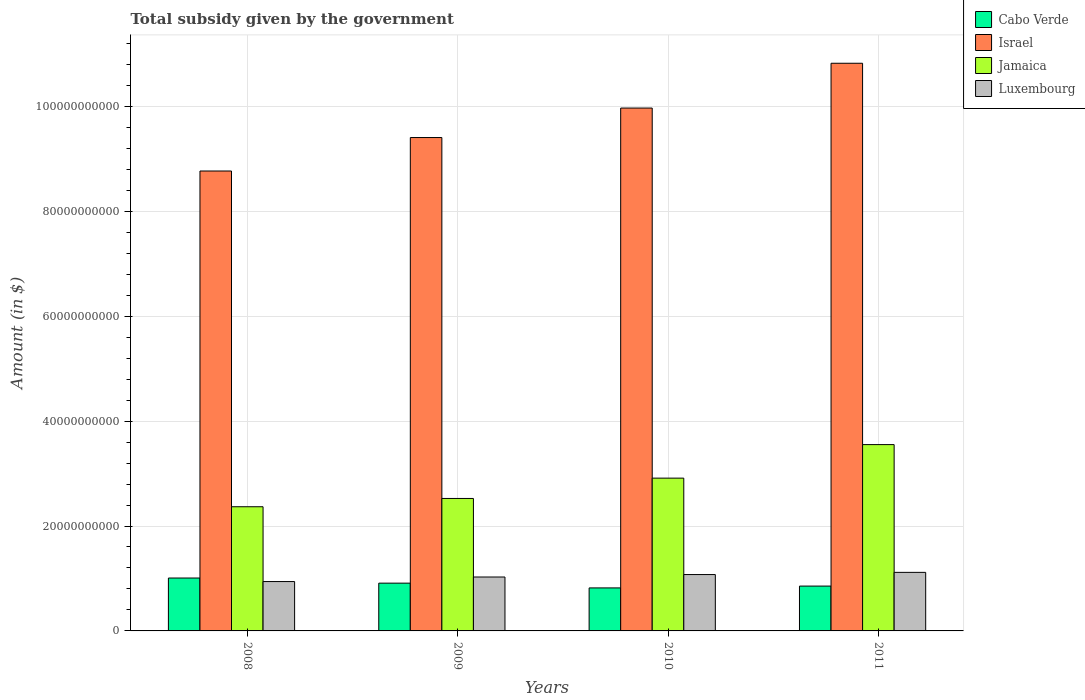How many bars are there on the 1st tick from the left?
Keep it short and to the point. 4. What is the label of the 2nd group of bars from the left?
Keep it short and to the point. 2009. What is the total revenue collected by the government in Israel in 2011?
Provide a short and direct response. 1.08e+11. Across all years, what is the maximum total revenue collected by the government in Jamaica?
Your answer should be compact. 3.55e+1. Across all years, what is the minimum total revenue collected by the government in Cabo Verde?
Offer a very short reply. 8.20e+09. In which year was the total revenue collected by the government in Jamaica maximum?
Ensure brevity in your answer.  2011. What is the total total revenue collected by the government in Luxembourg in the graph?
Ensure brevity in your answer.  4.16e+1. What is the difference between the total revenue collected by the government in Cabo Verde in 2008 and that in 2011?
Offer a very short reply. 1.54e+09. What is the difference between the total revenue collected by the government in Israel in 2008 and the total revenue collected by the government in Luxembourg in 2009?
Your answer should be very brief. 7.74e+1. What is the average total revenue collected by the government in Cabo Verde per year?
Offer a very short reply. 8.98e+09. In the year 2008, what is the difference between the total revenue collected by the government in Israel and total revenue collected by the government in Cabo Verde?
Ensure brevity in your answer.  7.76e+1. What is the ratio of the total revenue collected by the government in Luxembourg in 2009 to that in 2011?
Make the answer very short. 0.92. What is the difference between the highest and the second highest total revenue collected by the government in Jamaica?
Provide a short and direct response. 6.39e+09. What is the difference between the highest and the lowest total revenue collected by the government in Jamaica?
Your response must be concise. 1.18e+1. Is it the case that in every year, the sum of the total revenue collected by the government in Jamaica and total revenue collected by the government in Cabo Verde is greater than the sum of total revenue collected by the government in Israel and total revenue collected by the government in Luxembourg?
Your response must be concise. Yes. What does the 1st bar from the left in 2011 represents?
Give a very brief answer. Cabo Verde. What does the 4th bar from the right in 2009 represents?
Keep it short and to the point. Cabo Verde. Is it the case that in every year, the sum of the total revenue collected by the government in Luxembourg and total revenue collected by the government in Israel is greater than the total revenue collected by the government in Cabo Verde?
Offer a very short reply. Yes. Are all the bars in the graph horizontal?
Make the answer very short. No. How many years are there in the graph?
Provide a succinct answer. 4. What is the difference between two consecutive major ticks on the Y-axis?
Give a very brief answer. 2.00e+1. Are the values on the major ticks of Y-axis written in scientific E-notation?
Keep it short and to the point. No. Does the graph contain grids?
Offer a very short reply. Yes. What is the title of the graph?
Provide a short and direct response. Total subsidy given by the government. What is the label or title of the X-axis?
Your answer should be compact. Years. What is the label or title of the Y-axis?
Make the answer very short. Amount (in $). What is the Amount (in $) of Cabo Verde in 2008?
Your answer should be very brief. 1.01e+1. What is the Amount (in $) of Israel in 2008?
Give a very brief answer. 8.77e+1. What is the Amount (in $) of Jamaica in 2008?
Provide a succinct answer. 2.37e+1. What is the Amount (in $) of Luxembourg in 2008?
Offer a terse response. 9.41e+09. What is the Amount (in $) in Cabo Verde in 2009?
Offer a terse response. 9.11e+09. What is the Amount (in $) of Israel in 2009?
Your response must be concise. 9.41e+1. What is the Amount (in $) of Jamaica in 2009?
Ensure brevity in your answer.  2.53e+1. What is the Amount (in $) of Luxembourg in 2009?
Provide a succinct answer. 1.03e+1. What is the Amount (in $) in Cabo Verde in 2010?
Offer a very short reply. 8.20e+09. What is the Amount (in $) of Israel in 2010?
Provide a short and direct response. 9.97e+1. What is the Amount (in $) in Jamaica in 2010?
Ensure brevity in your answer.  2.91e+1. What is the Amount (in $) in Luxembourg in 2010?
Your answer should be compact. 1.07e+1. What is the Amount (in $) in Cabo Verde in 2011?
Your answer should be compact. 8.55e+09. What is the Amount (in $) of Israel in 2011?
Provide a succinct answer. 1.08e+11. What is the Amount (in $) in Jamaica in 2011?
Provide a succinct answer. 3.55e+1. What is the Amount (in $) of Luxembourg in 2011?
Provide a short and direct response. 1.12e+1. Across all years, what is the maximum Amount (in $) of Cabo Verde?
Make the answer very short. 1.01e+1. Across all years, what is the maximum Amount (in $) of Israel?
Provide a succinct answer. 1.08e+11. Across all years, what is the maximum Amount (in $) in Jamaica?
Your answer should be very brief. 3.55e+1. Across all years, what is the maximum Amount (in $) of Luxembourg?
Give a very brief answer. 1.12e+1. Across all years, what is the minimum Amount (in $) in Cabo Verde?
Make the answer very short. 8.20e+09. Across all years, what is the minimum Amount (in $) of Israel?
Offer a very short reply. 8.77e+1. Across all years, what is the minimum Amount (in $) of Jamaica?
Ensure brevity in your answer.  2.37e+1. Across all years, what is the minimum Amount (in $) of Luxembourg?
Give a very brief answer. 9.41e+09. What is the total Amount (in $) in Cabo Verde in the graph?
Offer a terse response. 3.59e+1. What is the total Amount (in $) in Israel in the graph?
Offer a very short reply. 3.90e+11. What is the total Amount (in $) of Jamaica in the graph?
Provide a short and direct response. 1.14e+11. What is the total Amount (in $) in Luxembourg in the graph?
Offer a terse response. 4.16e+1. What is the difference between the Amount (in $) of Cabo Verde in 2008 and that in 2009?
Your response must be concise. 9.79e+08. What is the difference between the Amount (in $) in Israel in 2008 and that in 2009?
Provide a succinct answer. -6.38e+09. What is the difference between the Amount (in $) in Jamaica in 2008 and that in 2009?
Your response must be concise. -1.58e+09. What is the difference between the Amount (in $) of Luxembourg in 2008 and that in 2009?
Provide a succinct answer. -8.68e+08. What is the difference between the Amount (in $) in Cabo Verde in 2008 and that in 2010?
Give a very brief answer. 1.89e+09. What is the difference between the Amount (in $) in Israel in 2008 and that in 2010?
Ensure brevity in your answer.  -1.20e+1. What is the difference between the Amount (in $) of Jamaica in 2008 and that in 2010?
Your answer should be compact. -5.46e+09. What is the difference between the Amount (in $) in Luxembourg in 2008 and that in 2010?
Your answer should be very brief. -1.33e+09. What is the difference between the Amount (in $) in Cabo Verde in 2008 and that in 2011?
Offer a very short reply. 1.54e+09. What is the difference between the Amount (in $) in Israel in 2008 and that in 2011?
Provide a succinct answer. -2.05e+1. What is the difference between the Amount (in $) in Jamaica in 2008 and that in 2011?
Offer a very short reply. -1.18e+1. What is the difference between the Amount (in $) in Luxembourg in 2008 and that in 2011?
Provide a succinct answer. -1.75e+09. What is the difference between the Amount (in $) in Cabo Verde in 2009 and that in 2010?
Make the answer very short. 9.08e+08. What is the difference between the Amount (in $) of Israel in 2009 and that in 2010?
Provide a short and direct response. -5.62e+09. What is the difference between the Amount (in $) in Jamaica in 2009 and that in 2010?
Provide a short and direct response. -3.88e+09. What is the difference between the Amount (in $) of Luxembourg in 2009 and that in 2010?
Offer a terse response. -4.66e+08. What is the difference between the Amount (in $) in Cabo Verde in 2009 and that in 2011?
Provide a short and direct response. 5.60e+08. What is the difference between the Amount (in $) in Israel in 2009 and that in 2011?
Ensure brevity in your answer.  -1.42e+1. What is the difference between the Amount (in $) of Jamaica in 2009 and that in 2011?
Offer a terse response. -1.03e+1. What is the difference between the Amount (in $) of Luxembourg in 2009 and that in 2011?
Give a very brief answer. -8.83e+08. What is the difference between the Amount (in $) of Cabo Verde in 2010 and that in 2011?
Ensure brevity in your answer.  -3.49e+08. What is the difference between the Amount (in $) in Israel in 2010 and that in 2011?
Provide a succinct answer. -8.54e+09. What is the difference between the Amount (in $) of Jamaica in 2010 and that in 2011?
Offer a terse response. -6.39e+09. What is the difference between the Amount (in $) of Luxembourg in 2010 and that in 2011?
Ensure brevity in your answer.  -4.17e+08. What is the difference between the Amount (in $) of Cabo Verde in 2008 and the Amount (in $) of Israel in 2009?
Your response must be concise. -8.40e+1. What is the difference between the Amount (in $) of Cabo Verde in 2008 and the Amount (in $) of Jamaica in 2009?
Your response must be concise. -1.52e+1. What is the difference between the Amount (in $) of Cabo Verde in 2008 and the Amount (in $) of Luxembourg in 2009?
Make the answer very short. -1.94e+08. What is the difference between the Amount (in $) of Israel in 2008 and the Amount (in $) of Jamaica in 2009?
Make the answer very short. 6.24e+1. What is the difference between the Amount (in $) in Israel in 2008 and the Amount (in $) in Luxembourg in 2009?
Provide a short and direct response. 7.74e+1. What is the difference between the Amount (in $) in Jamaica in 2008 and the Amount (in $) in Luxembourg in 2009?
Your answer should be very brief. 1.34e+1. What is the difference between the Amount (in $) in Cabo Verde in 2008 and the Amount (in $) in Israel in 2010?
Provide a short and direct response. -8.96e+1. What is the difference between the Amount (in $) in Cabo Verde in 2008 and the Amount (in $) in Jamaica in 2010?
Provide a succinct answer. -1.90e+1. What is the difference between the Amount (in $) of Cabo Verde in 2008 and the Amount (in $) of Luxembourg in 2010?
Ensure brevity in your answer.  -6.60e+08. What is the difference between the Amount (in $) of Israel in 2008 and the Amount (in $) of Jamaica in 2010?
Your response must be concise. 5.85e+1. What is the difference between the Amount (in $) of Israel in 2008 and the Amount (in $) of Luxembourg in 2010?
Your answer should be very brief. 7.69e+1. What is the difference between the Amount (in $) of Jamaica in 2008 and the Amount (in $) of Luxembourg in 2010?
Provide a short and direct response. 1.29e+1. What is the difference between the Amount (in $) in Cabo Verde in 2008 and the Amount (in $) in Israel in 2011?
Offer a terse response. -9.81e+1. What is the difference between the Amount (in $) of Cabo Verde in 2008 and the Amount (in $) of Jamaica in 2011?
Your answer should be very brief. -2.54e+1. What is the difference between the Amount (in $) of Cabo Verde in 2008 and the Amount (in $) of Luxembourg in 2011?
Make the answer very short. -1.08e+09. What is the difference between the Amount (in $) in Israel in 2008 and the Amount (in $) in Jamaica in 2011?
Offer a terse response. 5.22e+1. What is the difference between the Amount (in $) in Israel in 2008 and the Amount (in $) in Luxembourg in 2011?
Ensure brevity in your answer.  7.65e+1. What is the difference between the Amount (in $) of Jamaica in 2008 and the Amount (in $) of Luxembourg in 2011?
Ensure brevity in your answer.  1.25e+1. What is the difference between the Amount (in $) of Cabo Verde in 2009 and the Amount (in $) of Israel in 2010?
Offer a very short reply. -9.06e+1. What is the difference between the Amount (in $) in Cabo Verde in 2009 and the Amount (in $) in Jamaica in 2010?
Your answer should be very brief. -2.00e+1. What is the difference between the Amount (in $) in Cabo Verde in 2009 and the Amount (in $) in Luxembourg in 2010?
Provide a short and direct response. -1.64e+09. What is the difference between the Amount (in $) of Israel in 2009 and the Amount (in $) of Jamaica in 2010?
Your answer should be very brief. 6.49e+1. What is the difference between the Amount (in $) in Israel in 2009 and the Amount (in $) in Luxembourg in 2010?
Give a very brief answer. 8.33e+1. What is the difference between the Amount (in $) in Jamaica in 2009 and the Amount (in $) in Luxembourg in 2010?
Your answer should be compact. 1.45e+1. What is the difference between the Amount (in $) of Cabo Verde in 2009 and the Amount (in $) of Israel in 2011?
Your response must be concise. -9.91e+1. What is the difference between the Amount (in $) in Cabo Verde in 2009 and the Amount (in $) in Jamaica in 2011?
Ensure brevity in your answer.  -2.64e+1. What is the difference between the Amount (in $) in Cabo Verde in 2009 and the Amount (in $) in Luxembourg in 2011?
Provide a short and direct response. -2.06e+09. What is the difference between the Amount (in $) of Israel in 2009 and the Amount (in $) of Jamaica in 2011?
Your answer should be compact. 5.85e+1. What is the difference between the Amount (in $) in Israel in 2009 and the Amount (in $) in Luxembourg in 2011?
Ensure brevity in your answer.  8.29e+1. What is the difference between the Amount (in $) in Jamaica in 2009 and the Amount (in $) in Luxembourg in 2011?
Provide a succinct answer. 1.41e+1. What is the difference between the Amount (in $) of Cabo Verde in 2010 and the Amount (in $) of Israel in 2011?
Your response must be concise. -1.00e+11. What is the difference between the Amount (in $) of Cabo Verde in 2010 and the Amount (in $) of Jamaica in 2011?
Your answer should be compact. -2.73e+1. What is the difference between the Amount (in $) of Cabo Verde in 2010 and the Amount (in $) of Luxembourg in 2011?
Give a very brief answer. -2.96e+09. What is the difference between the Amount (in $) in Israel in 2010 and the Amount (in $) in Jamaica in 2011?
Give a very brief answer. 6.42e+1. What is the difference between the Amount (in $) of Israel in 2010 and the Amount (in $) of Luxembourg in 2011?
Offer a very short reply. 8.85e+1. What is the difference between the Amount (in $) of Jamaica in 2010 and the Amount (in $) of Luxembourg in 2011?
Offer a terse response. 1.80e+1. What is the average Amount (in $) in Cabo Verde per year?
Give a very brief answer. 8.98e+09. What is the average Amount (in $) in Israel per year?
Provide a succinct answer. 9.74e+1. What is the average Amount (in $) of Jamaica per year?
Provide a short and direct response. 2.84e+1. What is the average Amount (in $) in Luxembourg per year?
Your answer should be very brief. 1.04e+1. In the year 2008, what is the difference between the Amount (in $) in Cabo Verde and Amount (in $) in Israel?
Make the answer very short. -7.76e+1. In the year 2008, what is the difference between the Amount (in $) of Cabo Verde and Amount (in $) of Jamaica?
Offer a very short reply. -1.36e+1. In the year 2008, what is the difference between the Amount (in $) of Cabo Verde and Amount (in $) of Luxembourg?
Offer a terse response. 6.74e+08. In the year 2008, what is the difference between the Amount (in $) in Israel and Amount (in $) in Jamaica?
Keep it short and to the point. 6.40e+1. In the year 2008, what is the difference between the Amount (in $) in Israel and Amount (in $) in Luxembourg?
Offer a very short reply. 7.83e+1. In the year 2008, what is the difference between the Amount (in $) of Jamaica and Amount (in $) of Luxembourg?
Provide a short and direct response. 1.43e+1. In the year 2009, what is the difference between the Amount (in $) of Cabo Verde and Amount (in $) of Israel?
Provide a short and direct response. -8.50e+1. In the year 2009, what is the difference between the Amount (in $) of Cabo Verde and Amount (in $) of Jamaica?
Offer a terse response. -1.61e+1. In the year 2009, what is the difference between the Amount (in $) of Cabo Verde and Amount (in $) of Luxembourg?
Provide a short and direct response. -1.17e+09. In the year 2009, what is the difference between the Amount (in $) of Israel and Amount (in $) of Jamaica?
Offer a terse response. 6.88e+1. In the year 2009, what is the difference between the Amount (in $) of Israel and Amount (in $) of Luxembourg?
Give a very brief answer. 8.38e+1. In the year 2009, what is the difference between the Amount (in $) of Jamaica and Amount (in $) of Luxembourg?
Give a very brief answer. 1.50e+1. In the year 2010, what is the difference between the Amount (in $) in Cabo Verde and Amount (in $) in Israel?
Provide a short and direct response. -9.15e+1. In the year 2010, what is the difference between the Amount (in $) of Cabo Verde and Amount (in $) of Jamaica?
Your answer should be compact. -2.09e+1. In the year 2010, what is the difference between the Amount (in $) of Cabo Verde and Amount (in $) of Luxembourg?
Your answer should be compact. -2.55e+09. In the year 2010, what is the difference between the Amount (in $) of Israel and Amount (in $) of Jamaica?
Your response must be concise. 7.06e+1. In the year 2010, what is the difference between the Amount (in $) in Israel and Amount (in $) in Luxembourg?
Your answer should be compact. 8.89e+1. In the year 2010, what is the difference between the Amount (in $) in Jamaica and Amount (in $) in Luxembourg?
Keep it short and to the point. 1.84e+1. In the year 2011, what is the difference between the Amount (in $) of Cabo Verde and Amount (in $) of Israel?
Your answer should be compact. -9.97e+1. In the year 2011, what is the difference between the Amount (in $) in Cabo Verde and Amount (in $) in Jamaica?
Ensure brevity in your answer.  -2.70e+1. In the year 2011, what is the difference between the Amount (in $) of Cabo Verde and Amount (in $) of Luxembourg?
Offer a terse response. -2.62e+09. In the year 2011, what is the difference between the Amount (in $) in Israel and Amount (in $) in Jamaica?
Offer a terse response. 7.27e+1. In the year 2011, what is the difference between the Amount (in $) of Israel and Amount (in $) of Luxembourg?
Ensure brevity in your answer.  9.71e+1. In the year 2011, what is the difference between the Amount (in $) in Jamaica and Amount (in $) in Luxembourg?
Provide a short and direct response. 2.44e+1. What is the ratio of the Amount (in $) in Cabo Verde in 2008 to that in 2009?
Make the answer very short. 1.11. What is the ratio of the Amount (in $) in Israel in 2008 to that in 2009?
Offer a very short reply. 0.93. What is the ratio of the Amount (in $) of Jamaica in 2008 to that in 2009?
Ensure brevity in your answer.  0.94. What is the ratio of the Amount (in $) in Luxembourg in 2008 to that in 2009?
Provide a succinct answer. 0.92. What is the ratio of the Amount (in $) in Cabo Verde in 2008 to that in 2010?
Your answer should be compact. 1.23. What is the ratio of the Amount (in $) of Israel in 2008 to that in 2010?
Keep it short and to the point. 0.88. What is the ratio of the Amount (in $) of Jamaica in 2008 to that in 2010?
Make the answer very short. 0.81. What is the ratio of the Amount (in $) in Luxembourg in 2008 to that in 2010?
Offer a very short reply. 0.88. What is the ratio of the Amount (in $) of Cabo Verde in 2008 to that in 2011?
Make the answer very short. 1.18. What is the ratio of the Amount (in $) of Israel in 2008 to that in 2011?
Your answer should be very brief. 0.81. What is the ratio of the Amount (in $) of Jamaica in 2008 to that in 2011?
Your answer should be very brief. 0.67. What is the ratio of the Amount (in $) in Luxembourg in 2008 to that in 2011?
Make the answer very short. 0.84. What is the ratio of the Amount (in $) in Cabo Verde in 2009 to that in 2010?
Offer a very short reply. 1.11. What is the ratio of the Amount (in $) of Israel in 2009 to that in 2010?
Keep it short and to the point. 0.94. What is the ratio of the Amount (in $) in Jamaica in 2009 to that in 2010?
Give a very brief answer. 0.87. What is the ratio of the Amount (in $) of Luxembourg in 2009 to that in 2010?
Your answer should be compact. 0.96. What is the ratio of the Amount (in $) of Cabo Verde in 2009 to that in 2011?
Provide a short and direct response. 1.07. What is the ratio of the Amount (in $) of Israel in 2009 to that in 2011?
Make the answer very short. 0.87. What is the ratio of the Amount (in $) in Jamaica in 2009 to that in 2011?
Keep it short and to the point. 0.71. What is the ratio of the Amount (in $) of Luxembourg in 2009 to that in 2011?
Provide a short and direct response. 0.92. What is the ratio of the Amount (in $) in Cabo Verde in 2010 to that in 2011?
Offer a very short reply. 0.96. What is the ratio of the Amount (in $) of Israel in 2010 to that in 2011?
Your response must be concise. 0.92. What is the ratio of the Amount (in $) of Jamaica in 2010 to that in 2011?
Provide a short and direct response. 0.82. What is the ratio of the Amount (in $) of Luxembourg in 2010 to that in 2011?
Keep it short and to the point. 0.96. What is the difference between the highest and the second highest Amount (in $) of Cabo Verde?
Give a very brief answer. 9.79e+08. What is the difference between the highest and the second highest Amount (in $) in Israel?
Keep it short and to the point. 8.54e+09. What is the difference between the highest and the second highest Amount (in $) of Jamaica?
Make the answer very short. 6.39e+09. What is the difference between the highest and the second highest Amount (in $) of Luxembourg?
Your answer should be compact. 4.17e+08. What is the difference between the highest and the lowest Amount (in $) of Cabo Verde?
Make the answer very short. 1.89e+09. What is the difference between the highest and the lowest Amount (in $) in Israel?
Keep it short and to the point. 2.05e+1. What is the difference between the highest and the lowest Amount (in $) in Jamaica?
Your response must be concise. 1.18e+1. What is the difference between the highest and the lowest Amount (in $) in Luxembourg?
Ensure brevity in your answer.  1.75e+09. 